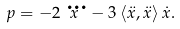<formula> <loc_0><loc_0><loc_500><loc_500>p = - 2 \dddot { x } - 3 \left \langle \ddot { x } , \ddot { x } \right \rangle \dot { x } .</formula> 